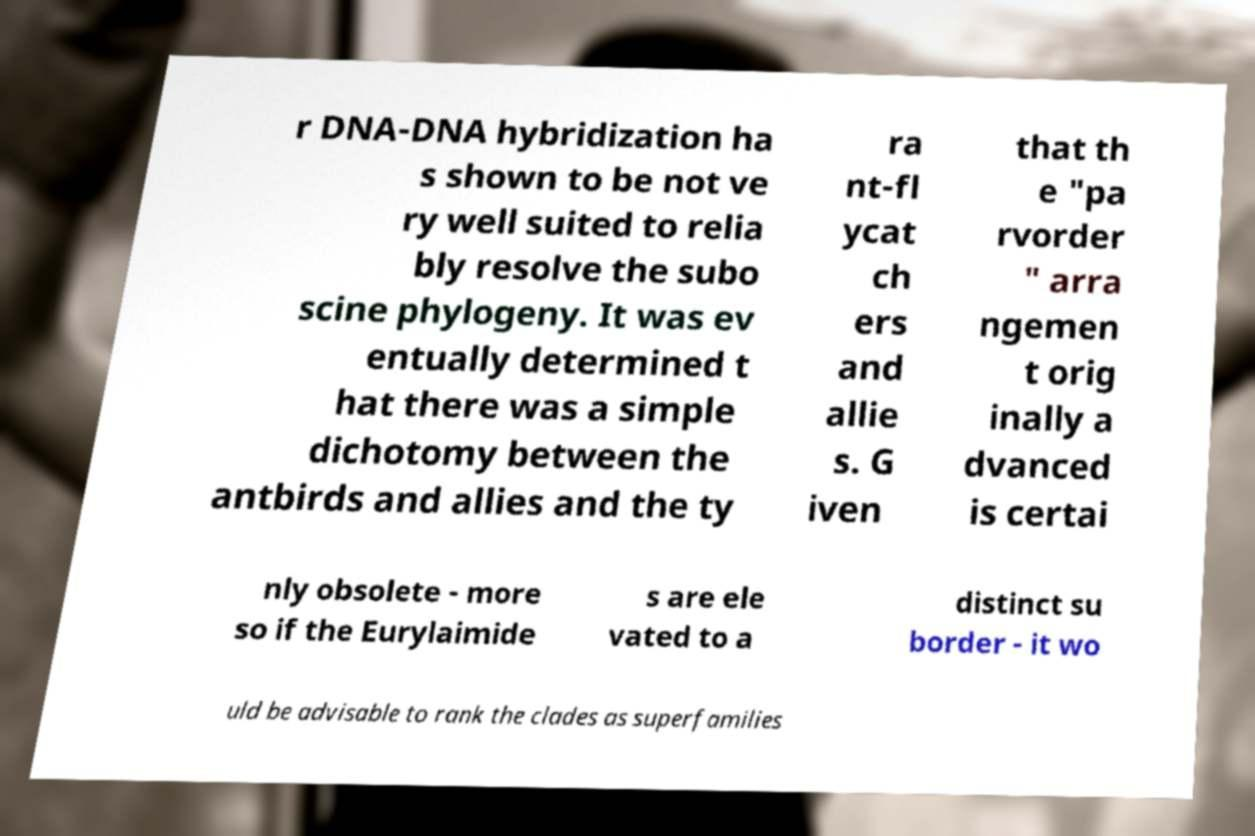Please identify and transcribe the text found in this image. r DNA-DNA hybridization ha s shown to be not ve ry well suited to relia bly resolve the subo scine phylogeny. It was ev entually determined t hat there was a simple dichotomy between the antbirds and allies and the ty ra nt-fl ycat ch ers and allie s. G iven that th e "pa rvorder " arra ngemen t orig inally a dvanced is certai nly obsolete - more so if the Eurylaimide s are ele vated to a distinct su border - it wo uld be advisable to rank the clades as superfamilies 